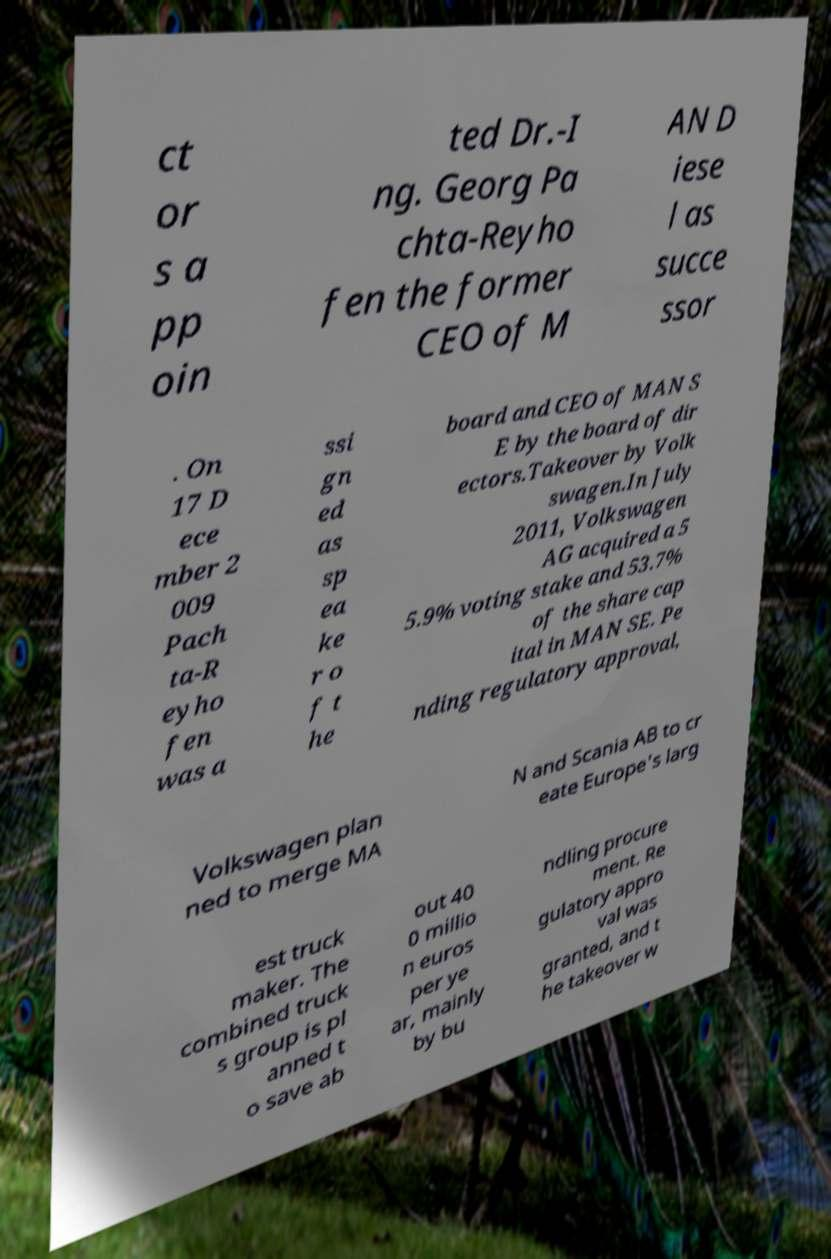There's text embedded in this image that I need extracted. Can you transcribe it verbatim? ct or s a pp oin ted Dr.-I ng. Georg Pa chta-Reyho fen the former CEO of M AN D iese l as succe ssor . On 17 D ece mber 2 009 Pach ta-R eyho fen was a ssi gn ed as sp ea ke r o f t he board and CEO of MAN S E by the board of dir ectors.Takeover by Volk swagen.In July 2011, Volkswagen AG acquired a 5 5.9% voting stake and 53.7% of the share cap ital in MAN SE. Pe nding regulatory approval, Volkswagen plan ned to merge MA N and Scania AB to cr eate Europe's larg est truck maker. The combined truck s group is pl anned t o save ab out 40 0 millio n euros per ye ar, mainly by bu ndling procure ment. Re gulatory appro val was granted, and t he takeover w 